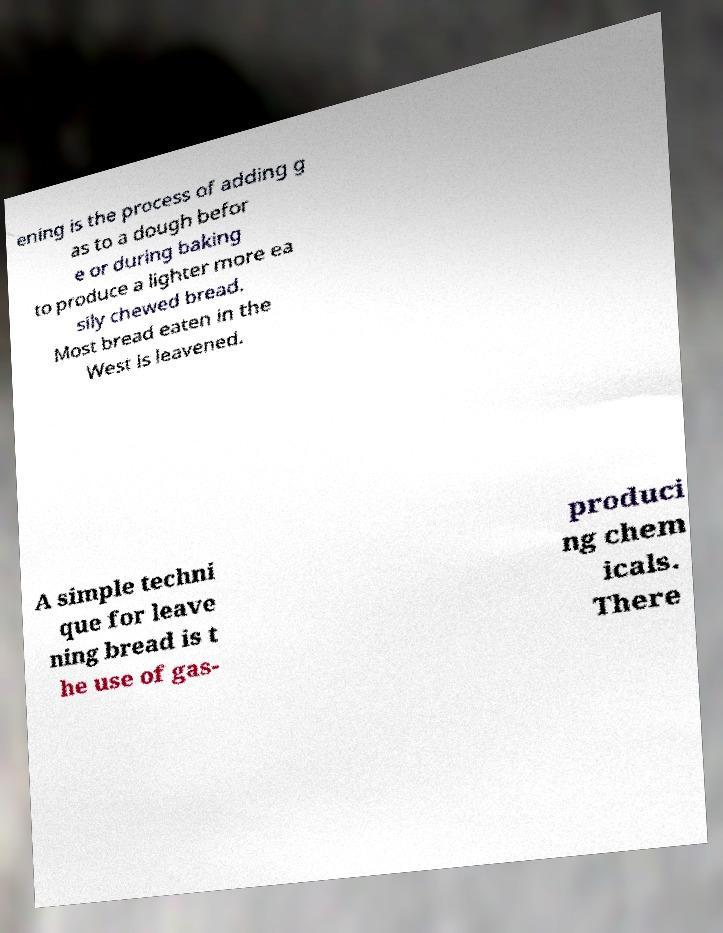I need the written content from this picture converted into text. Can you do that? ening is the process of adding g as to a dough befor e or during baking to produce a lighter more ea sily chewed bread. Most bread eaten in the West is leavened. A simple techni que for leave ning bread is t he use of gas- produci ng chem icals. There 